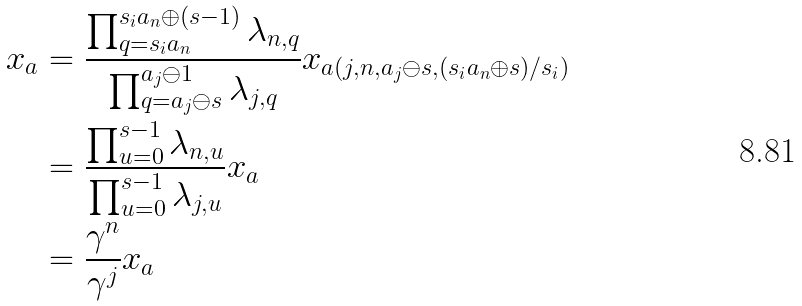Convert formula to latex. <formula><loc_0><loc_0><loc_500><loc_500>x _ { a } & = \frac { \prod _ { q = s _ { i } a _ { n } } ^ { s _ { i } a _ { n } \oplus ( s - 1 ) } \lambda _ { n , q } } { \prod _ { q = a _ { j } \ominus s } ^ { a _ { j } \ominus 1 } \lambda _ { j , q } } x _ { a ( j , n , a _ { j } \ominus s , ( s _ { i } a _ { n } \oplus s ) / s _ { i } ) } \\ & = \frac { \prod _ { u = 0 } ^ { s - 1 } \lambda _ { n , u } } { \prod _ { u = 0 } ^ { s - 1 } \lambda _ { j , u } } x _ { a } \\ & = \frac { \gamma ^ { n } } { \gamma ^ { j } } x _ { a }</formula> 